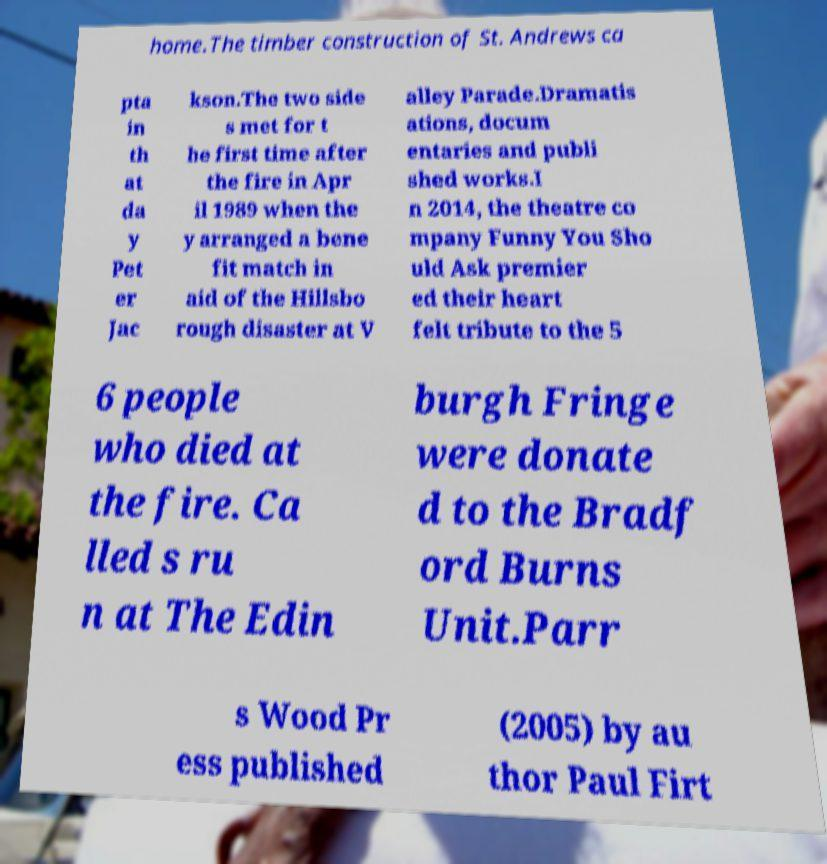For documentation purposes, I need the text within this image transcribed. Could you provide that? home.The timber construction of St. Andrews ca pta in th at da y Pet er Jac kson.The two side s met for t he first time after the fire in Apr il 1989 when the y arranged a bene fit match in aid of the Hillsbo rough disaster at V alley Parade.Dramatis ations, docum entaries and publi shed works.I n 2014, the theatre co mpany Funny You Sho uld Ask premier ed their heart felt tribute to the 5 6 people who died at the fire. Ca lled s ru n at The Edin burgh Fringe were donate d to the Bradf ord Burns Unit.Parr s Wood Pr ess published (2005) by au thor Paul Firt 